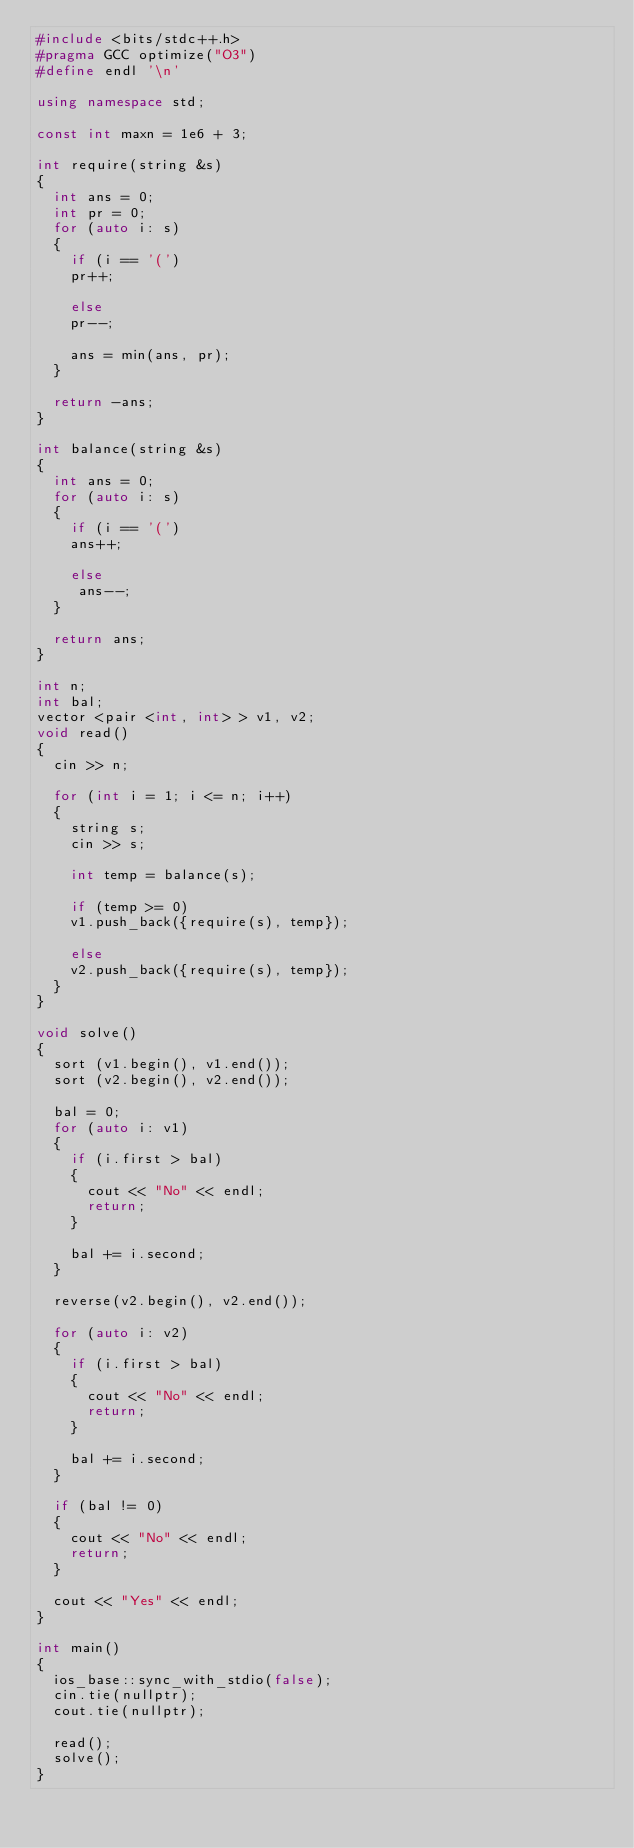<code> <loc_0><loc_0><loc_500><loc_500><_C++_>#include <bits/stdc++.h>
#pragma GCC optimize("O3")
#define endl '\n'

using namespace std;

const int maxn = 1e6 + 3; 

int require(string &s)
{
	int ans = 0;
	int pr = 0;
	for (auto i: s)
	{
		if (i == '(')
		pr++;
		
		else 
		pr--;
		
		ans = min(ans, pr); 
	}
	
	return -ans; 
}

int balance(string &s)
{
	int ans = 0;
	for (auto i: s)
	{
		if (i == '(')
		ans++;
		
		else
		 ans--;
	}
	
	return ans; 
}

int n;
int bal;
vector <pair <int, int> > v1, v2;  
void read()
{
	cin >> n;
	
	for (int i = 1; i <= n; i++)
	{
		string s; 
		cin >> s;
		
		int temp = balance(s);
		
		if (temp >= 0)
		v1.push_back({require(s), temp});
		
		else
		v2.push_back({require(s), temp});
	}	
}

void solve()
{
	sort (v1.begin(), v1.end());
	sort (v2.begin(), v2.end());
	
	bal = 0;
	for (auto i: v1)
	{
		if (i.first > bal)
		{
			cout << "No" << endl;
			return; 
		}
		
		bal += i.second; 
	}
	
	reverse(v2.begin(), v2.end());
	
	for (auto i: v2)
	{
		if (i.first > bal)
		{
			cout << "No" << endl;
			return;
		}
		
		bal += i.second; 
	}
	
	if (bal != 0)
	{
		cout << "No" << endl; 
		return;
	}
	
	cout << "Yes" << endl; 
}

int main()
{
	ios_base::sync_with_stdio(false);
	cin.tie(nullptr);
	cout.tie(nullptr);
	
	read();
	solve();
}
</code> 